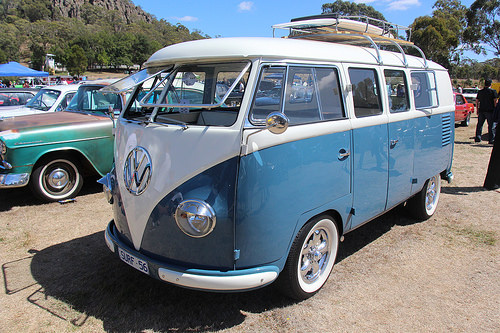<image>
Is there a van behind the car? No. The van is not behind the car. From this viewpoint, the van appears to be positioned elsewhere in the scene. 